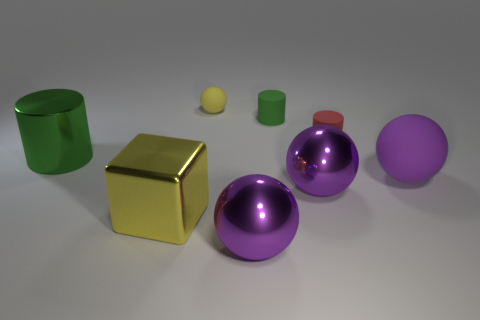What is the size of the object that is the same color as the big block?
Make the answer very short. Small. Is there a big red ball that has the same material as the tiny red cylinder?
Provide a succinct answer. No. What color is the big cube?
Provide a short and direct response. Yellow. What size is the purple metal ball that is right of the large metallic sphere on the left side of the green thing to the right of the big shiny cylinder?
Keep it short and to the point. Large. How many other objects are the same shape as the yellow rubber object?
Your response must be concise. 3. There is a large object that is both to the left of the small rubber ball and behind the shiny cube; what is its color?
Provide a succinct answer. Green. Are there any other things that have the same size as the red object?
Your answer should be very brief. Yes. There is a rubber thing in front of the large cylinder; is its color the same as the large block?
Your answer should be compact. No. What number of cubes are either small yellow matte things or large yellow shiny things?
Make the answer very short. 1. There is a metallic thing that is behind the big rubber thing; what is its shape?
Your answer should be compact. Cylinder. 